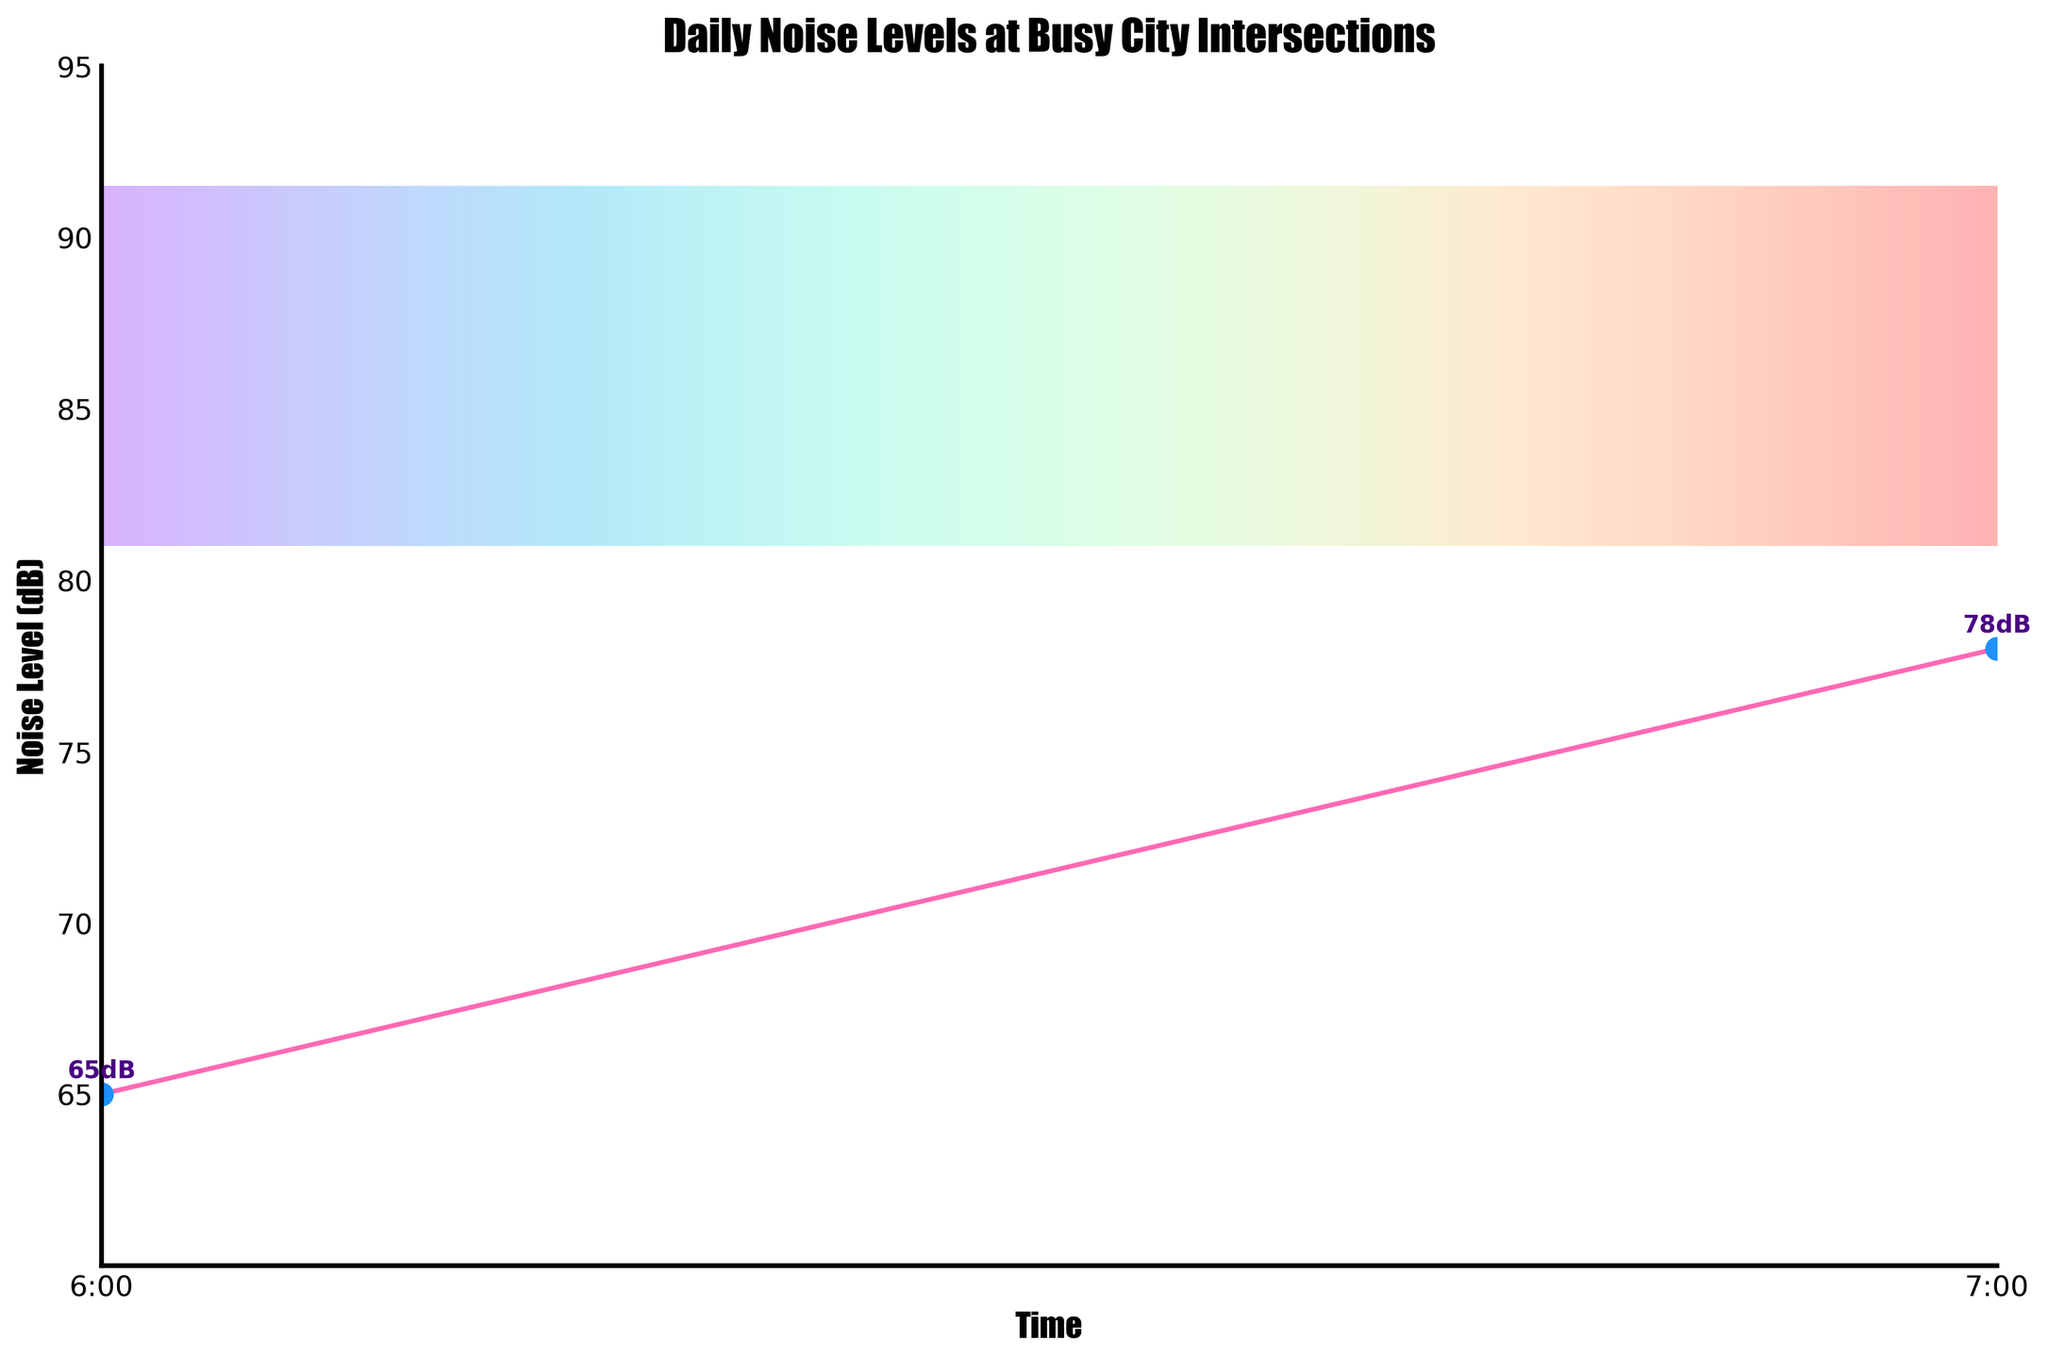Which time period has the highest noise level? The highest noise level is observed at 17:00 with a decibel level of 89 dB. This can be identified by locating the peak point in the plot.
Answer: 17:00 What is the difference in noise levels between 7:00 AM and 6:00 PM? At 7:00 AM, the noise level is 78 dB, and at 6:00 PM, it is 86 dB. The difference is calculated as 86 - 78. Hence, the difference is 8 dB.
Answer: 8 dB Around what time in the morning does the noise level peak, and what is the peak value? The noise level peaks at 8:00 AM in the morning, where the value reaches 85 dB. This can be identified by tracking the curve as it rises in the morning hours.
Answer: 8:00 AM, 85 dB How does the noise level at noon compare to the noise level at midnight? The noise level at noon (12:00 PM) is 83 dB, while at midnight (00:00), it is 68 dB. The noise level at noon is higher than at midnight.
Answer: Noon is higher than midnight If you average the noise levels at 10:00, 11:00, and noon, what value do you get? The noise levels at 10:00, 11:00, and noon are 80 dB, 79 dB, and 83 dB respectively. To find the average: (80 + 79 + 83) / 3 = 242 / 3 = 80.67 dB (rounded to two decimal places).
Answer: 80.67 dB Which time period shows a noticeable drop in noise level in the evening? There is a noticeable drop from 21:00 (77 dB) to 22:00 (75 dB). This can be seen as a downward trend on the plot.
Answer: 21:00 to 22:00 At what times do noise levels intersect at approximately 82 dB? The noise levels intersect at approximately 82 dB at 9:00 and 14:00. By tracing the plot lines, these intersections can be observed.
Answer: 9:00 and 14:00 What is the range of noise levels observed in the plot throughout the day? The range of noise levels is found by subtracting the lowest value from the highest value. The lowest noise level is 65 dB at 6:00, and the highest is 89 dB at 17:00. So, the range is 89 - 65 = 24 dB.
Answer: 24 dB How does the noise level change from 17:00 to 19:00? The noise level at 17:00 is 89 dB and at 19:00 is 83 dB. The noise level decreases by 89 - 83 = 6 dB over this period.
Answer: Decreases by 6 dB What is the overall trend in noise levels from 6:00 AM to 10:00 AM? The noise levels increase from 65 dB at 6:00 AM to 80 dB at 10:00 AM. This can be seen as a rising trend in the plot.
Answer: Increasing trend 